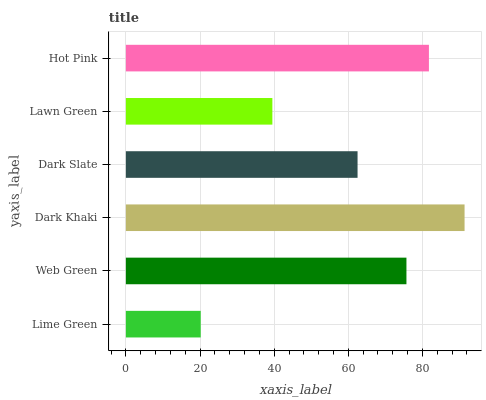Is Lime Green the minimum?
Answer yes or no. Yes. Is Dark Khaki the maximum?
Answer yes or no. Yes. Is Web Green the minimum?
Answer yes or no. No. Is Web Green the maximum?
Answer yes or no. No. Is Web Green greater than Lime Green?
Answer yes or no. Yes. Is Lime Green less than Web Green?
Answer yes or no. Yes. Is Lime Green greater than Web Green?
Answer yes or no. No. Is Web Green less than Lime Green?
Answer yes or no. No. Is Web Green the high median?
Answer yes or no. Yes. Is Dark Slate the low median?
Answer yes or no. Yes. Is Hot Pink the high median?
Answer yes or no. No. Is Lime Green the low median?
Answer yes or no. No. 